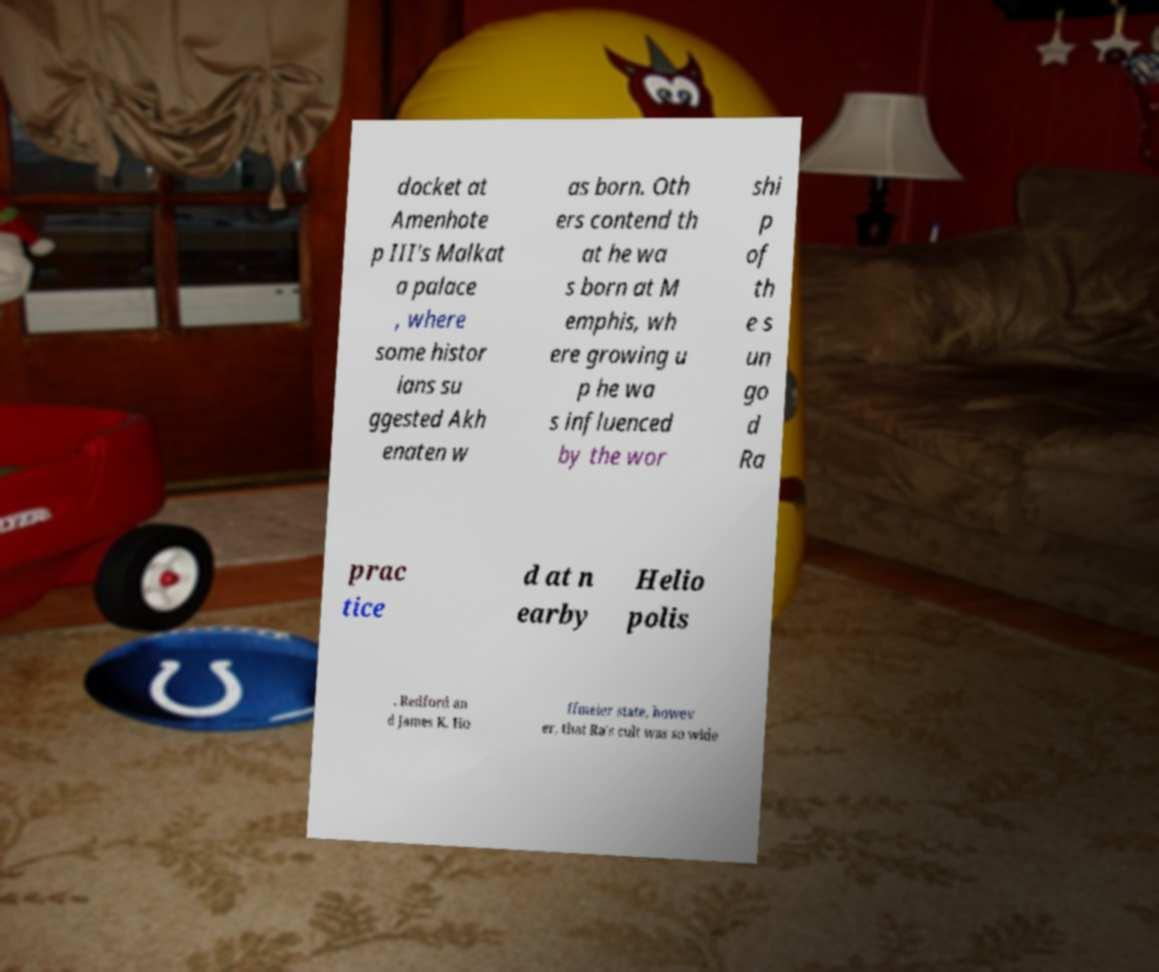Can you read and provide the text displayed in the image?This photo seems to have some interesting text. Can you extract and type it out for me? docket at Amenhote p III's Malkat a palace , where some histor ians su ggested Akh enaten w as born. Oth ers contend th at he wa s born at M emphis, wh ere growing u p he wa s influenced by the wor shi p of th e s un go d Ra prac tice d at n earby Helio polis . Redford an d James K. Ho ffmeier state, howev er, that Ra's cult was so wide 